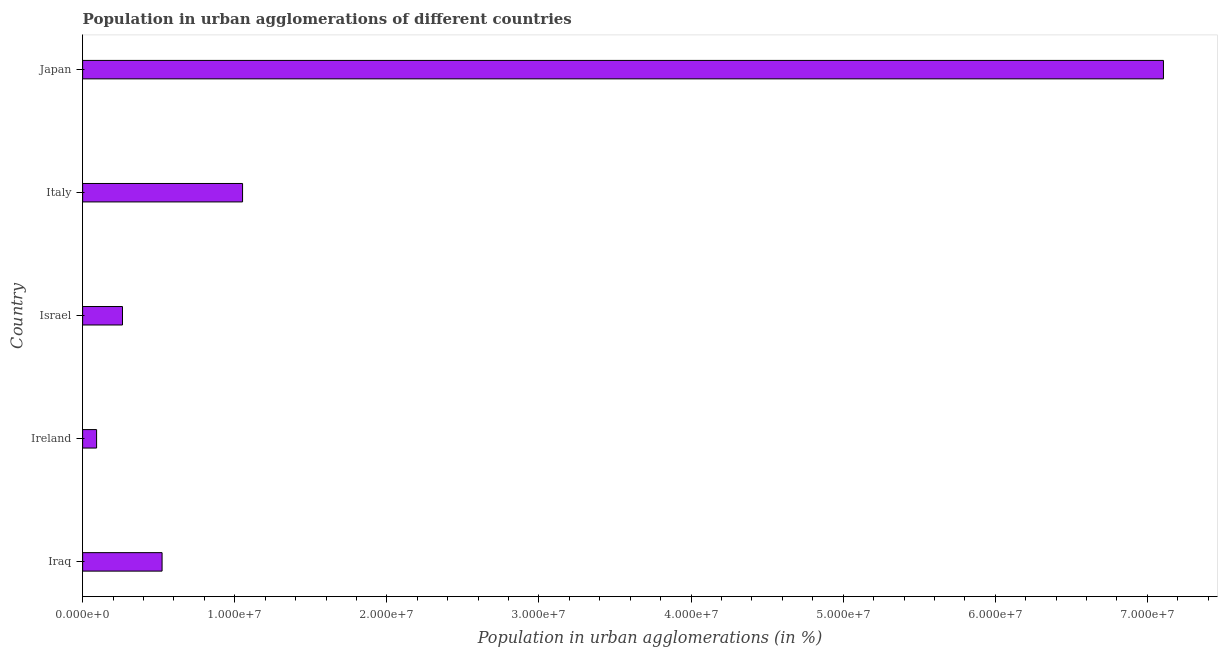Does the graph contain grids?
Your response must be concise. No. What is the title of the graph?
Your answer should be very brief. Population in urban agglomerations of different countries. What is the label or title of the X-axis?
Offer a very short reply. Population in urban agglomerations (in %). What is the label or title of the Y-axis?
Make the answer very short. Country. What is the population in urban agglomerations in Israel?
Provide a succinct answer. 2.62e+06. Across all countries, what is the maximum population in urban agglomerations?
Your response must be concise. 7.11e+07. Across all countries, what is the minimum population in urban agglomerations?
Provide a short and direct response. 9.17e+05. In which country was the population in urban agglomerations maximum?
Provide a short and direct response. Japan. In which country was the population in urban agglomerations minimum?
Provide a succinct answer. Ireland. What is the sum of the population in urban agglomerations?
Your answer should be very brief. 9.03e+07. What is the difference between the population in urban agglomerations in Iraq and Italy?
Provide a short and direct response. -5.29e+06. What is the average population in urban agglomerations per country?
Offer a terse response. 1.81e+07. What is the median population in urban agglomerations?
Ensure brevity in your answer.  5.22e+06. In how many countries, is the population in urban agglomerations greater than 20000000 %?
Your answer should be very brief. 1. What is the ratio of the population in urban agglomerations in Iraq to that in Japan?
Provide a succinct answer. 0.07. Is the population in urban agglomerations in Iraq less than that in Israel?
Keep it short and to the point. No. Is the difference between the population in urban agglomerations in Iraq and Japan greater than the difference between any two countries?
Make the answer very short. No. What is the difference between the highest and the second highest population in urban agglomerations?
Offer a terse response. 6.05e+07. What is the difference between the highest and the lowest population in urban agglomerations?
Offer a terse response. 7.01e+07. In how many countries, is the population in urban agglomerations greater than the average population in urban agglomerations taken over all countries?
Ensure brevity in your answer.  1. How many bars are there?
Your answer should be very brief. 5. Are all the bars in the graph horizontal?
Give a very brief answer. Yes. What is the Population in urban agglomerations (in %) in Iraq?
Provide a short and direct response. 5.22e+06. What is the Population in urban agglomerations (in %) of Ireland?
Provide a succinct answer. 9.17e+05. What is the Population in urban agglomerations (in %) in Israel?
Make the answer very short. 2.62e+06. What is the Population in urban agglomerations (in %) of Italy?
Give a very brief answer. 1.05e+07. What is the Population in urban agglomerations (in %) of Japan?
Offer a very short reply. 7.11e+07. What is the difference between the Population in urban agglomerations (in %) in Iraq and Ireland?
Provide a succinct answer. 4.31e+06. What is the difference between the Population in urban agglomerations (in %) in Iraq and Israel?
Your response must be concise. 2.60e+06. What is the difference between the Population in urban agglomerations (in %) in Iraq and Italy?
Give a very brief answer. -5.29e+06. What is the difference between the Population in urban agglomerations (in %) in Iraq and Japan?
Your response must be concise. -6.58e+07. What is the difference between the Population in urban agglomerations (in %) in Ireland and Israel?
Your response must be concise. -1.70e+06. What is the difference between the Population in urban agglomerations (in %) in Ireland and Italy?
Offer a terse response. -9.60e+06. What is the difference between the Population in urban agglomerations (in %) in Ireland and Japan?
Provide a succinct answer. -7.01e+07. What is the difference between the Population in urban agglomerations (in %) in Israel and Italy?
Your answer should be compact. -7.89e+06. What is the difference between the Population in urban agglomerations (in %) in Israel and Japan?
Offer a very short reply. -6.84e+07. What is the difference between the Population in urban agglomerations (in %) in Italy and Japan?
Your answer should be very brief. -6.05e+07. What is the ratio of the Population in urban agglomerations (in %) in Iraq to that in Ireland?
Provide a short and direct response. 5.69. What is the ratio of the Population in urban agglomerations (in %) in Iraq to that in Israel?
Give a very brief answer. 1.99. What is the ratio of the Population in urban agglomerations (in %) in Iraq to that in Italy?
Offer a terse response. 0.5. What is the ratio of the Population in urban agglomerations (in %) in Iraq to that in Japan?
Give a very brief answer. 0.07. What is the ratio of the Population in urban agglomerations (in %) in Ireland to that in Italy?
Offer a terse response. 0.09. What is the ratio of the Population in urban agglomerations (in %) in Ireland to that in Japan?
Offer a terse response. 0.01. What is the ratio of the Population in urban agglomerations (in %) in Israel to that in Italy?
Make the answer very short. 0.25. What is the ratio of the Population in urban agglomerations (in %) in Israel to that in Japan?
Your answer should be compact. 0.04. What is the ratio of the Population in urban agglomerations (in %) in Italy to that in Japan?
Ensure brevity in your answer.  0.15. 